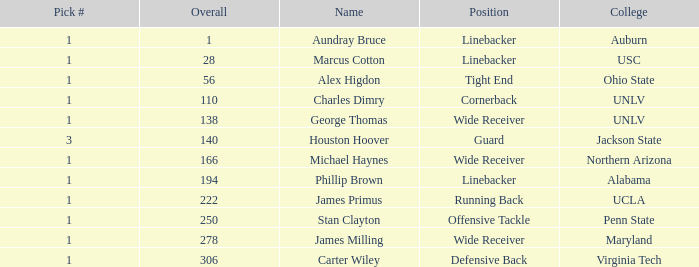What round was george thomas drafted in? 6.0. 